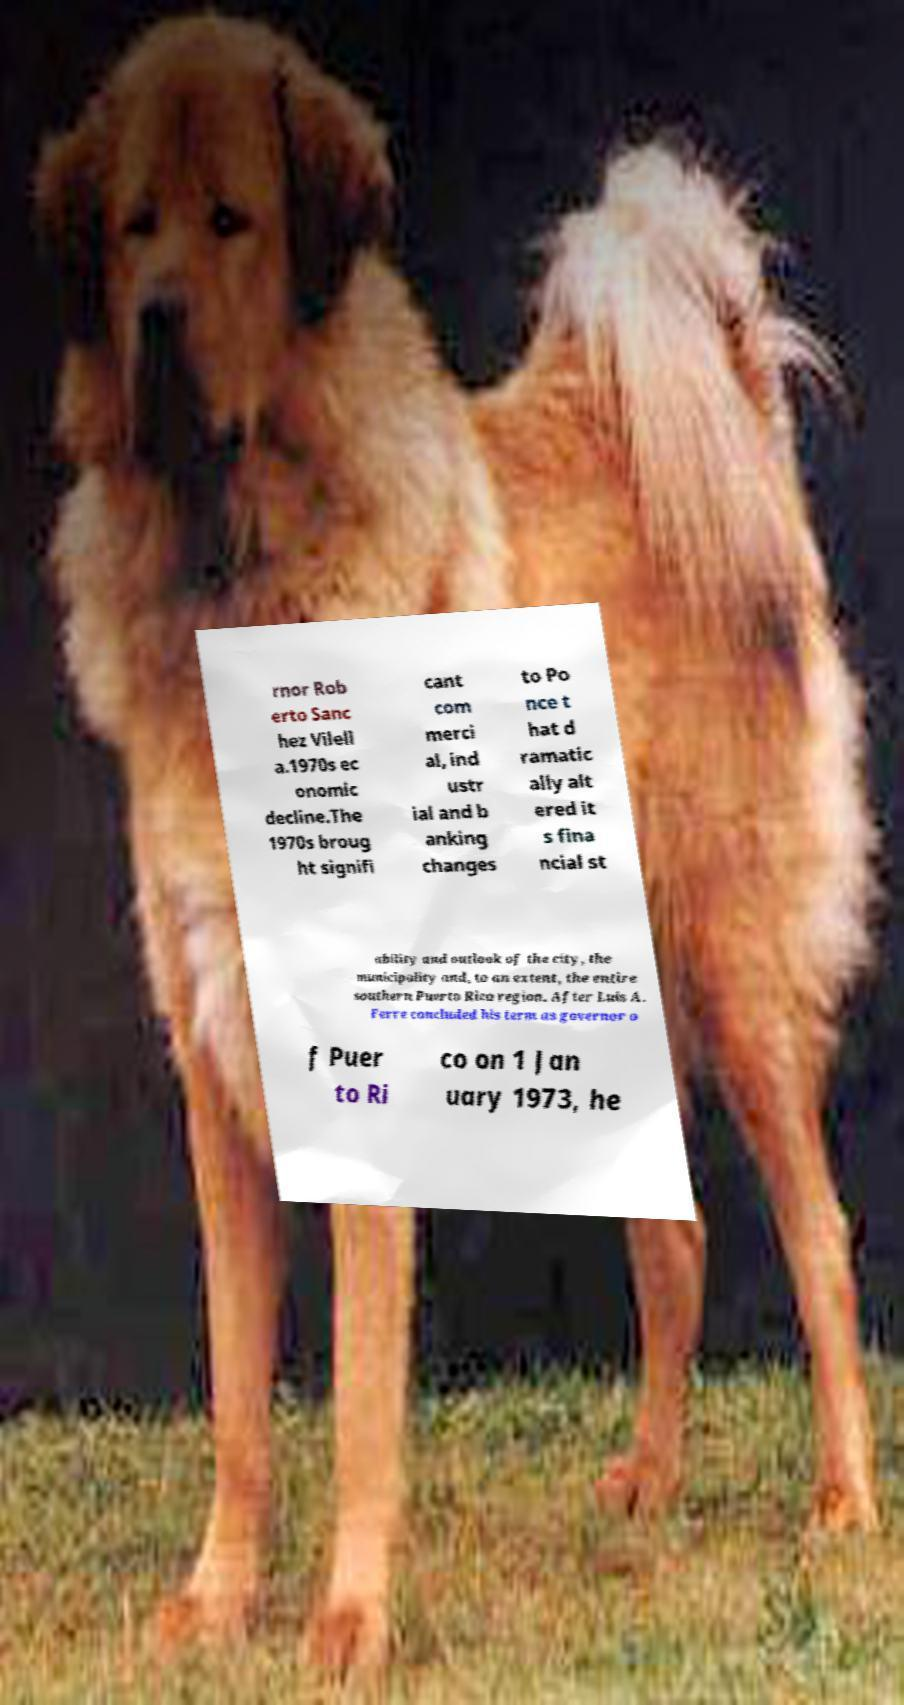There's text embedded in this image that I need extracted. Can you transcribe it verbatim? rnor Rob erto Sanc hez Vilell a.1970s ec onomic decline.The 1970s broug ht signifi cant com merci al, ind ustr ial and b anking changes to Po nce t hat d ramatic ally alt ered it s fina ncial st ability and outlook of the city, the municipality and, to an extent, the entire southern Puerto Rico region. After Luis A. Ferre concluded his term as governor o f Puer to Ri co on 1 Jan uary 1973, he 